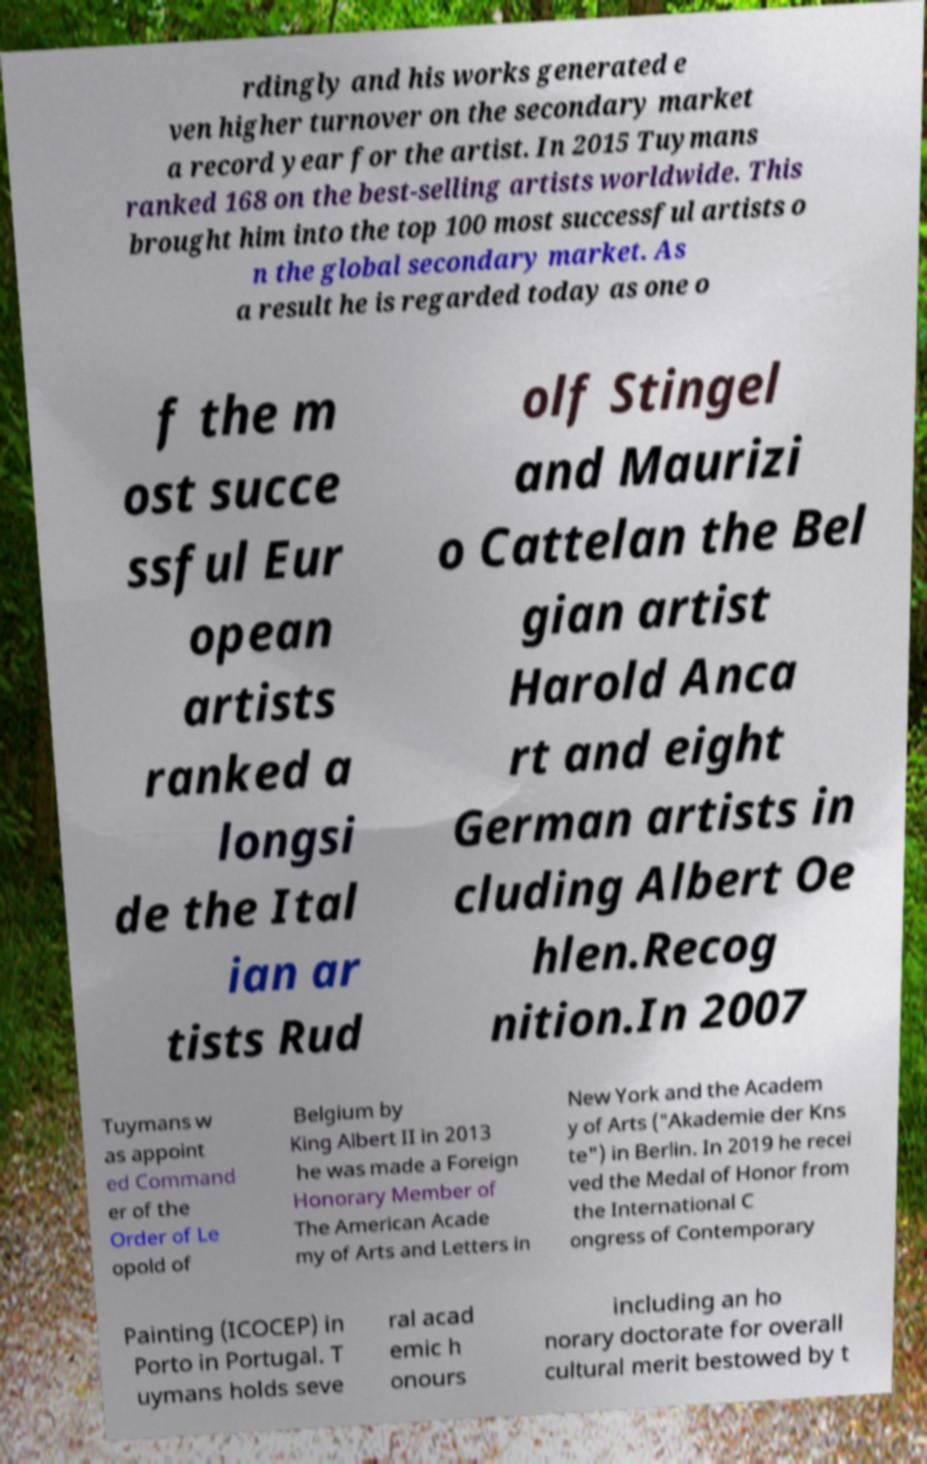What messages or text are displayed in this image? I need them in a readable, typed format. rdingly and his works generated e ven higher turnover on the secondary market a record year for the artist. In 2015 Tuymans ranked 168 on the best-selling artists worldwide. This brought him into the top 100 most successful artists o n the global secondary market. As a result he is regarded today as one o f the m ost succe ssful Eur opean artists ranked a longsi de the Ital ian ar tists Rud olf Stingel and Maurizi o Cattelan the Bel gian artist Harold Anca rt and eight German artists in cluding Albert Oe hlen.Recog nition.In 2007 Tuymans w as appoint ed Command er of the Order of Le opold of Belgium by King Albert II in 2013 he was made a Foreign Honorary Member of The American Acade my of Arts and Letters in New York and the Academ y of Arts ("Akademie der Kns te") in Berlin. In 2019 he recei ved the Medal of Honor from the International C ongress of Contemporary Painting (ICOCEP) in Porto in Portugal. T uymans holds seve ral acad emic h onours including an ho norary doctorate for overall cultural merit bestowed by t 